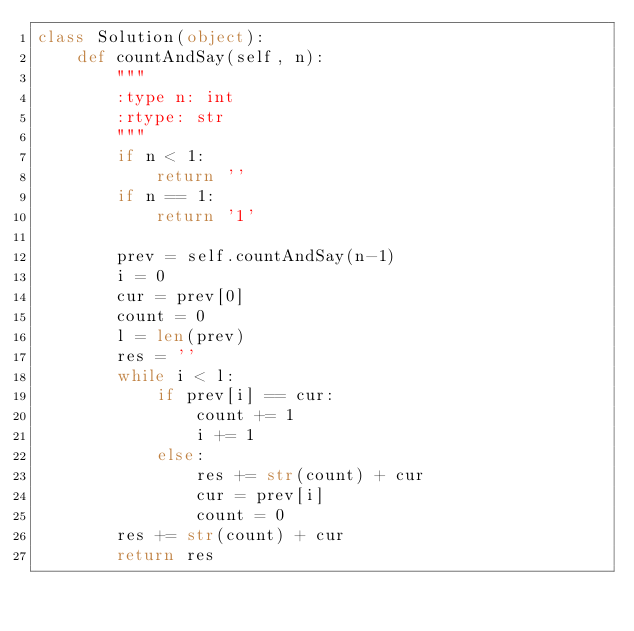<code> <loc_0><loc_0><loc_500><loc_500><_Python_>class Solution(object):    def countAndSay(self, n):        """        :type n: int        :rtype: str        """        if n < 1:            return ''        if n == 1:            return '1'                prev = self.countAndSay(n-1)        i = 0        cur = prev[0]        count = 0        l = len(prev)        res = ''        while i < l:            if prev[i] == cur:                count += 1                i += 1            else:                res += str(count) + cur                cur = prev[i]                count = 0        res += str(count) + cur        return res</code> 